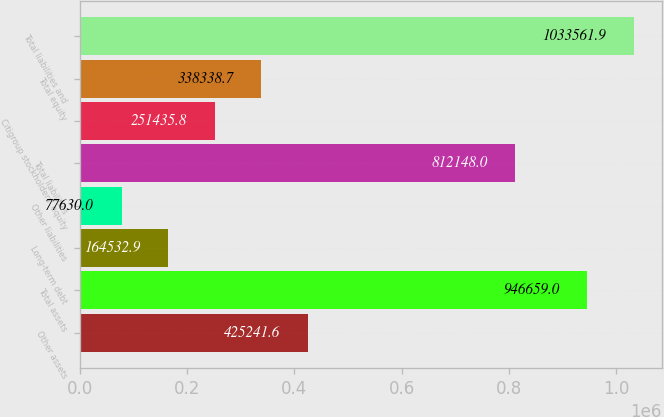Convert chart. <chart><loc_0><loc_0><loc_500><loc_500><bar_chart><fcel>Other assets<fcel>Total assets<fcel>Long-term debt<fcel>Other liabilities<fcel>Total liabilities<fcel>Citigroup stockholders' equity<fcel>Total equity<fcel>Total liabilities and<nl><fcel>425242<fcel>946659<fcel>164533<fcel>77630<fcel>812148<fcel>251436<fcel>338339<fcel>1.03356e+06<nl></chart> 